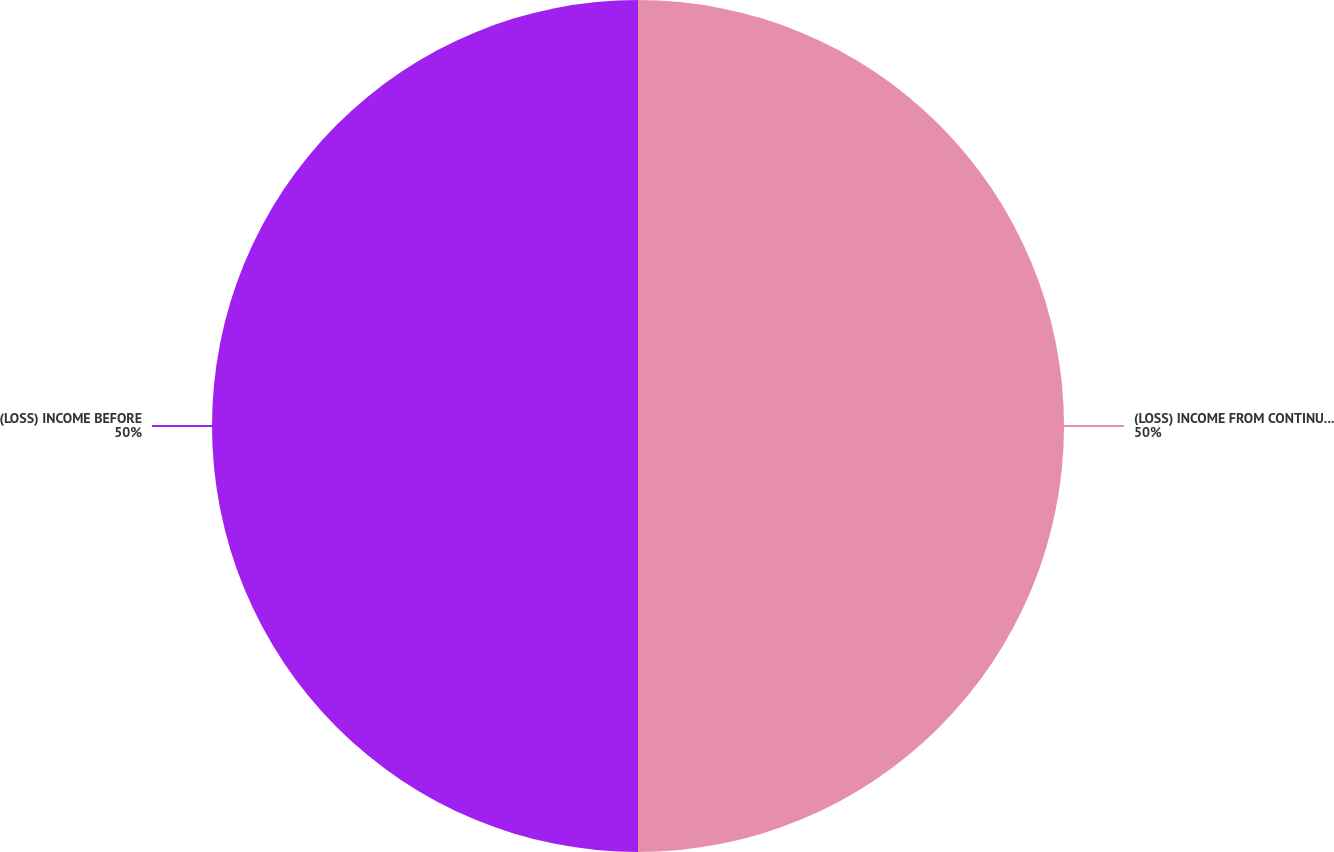Convert chart. <chart><loc_0><loc_0><loc_500><loc_500><pie_chart><fcel>(LOSS) INCOME FROM CONTINUING<fcel>(LOSS) INCOME BEFORE<nl><fcel>50.0%<fcel>50.0%<nl></chart> 